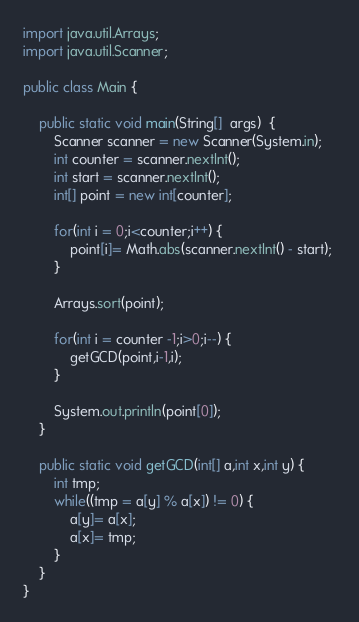Convert code to text. <code><loc_0><loc_0><loc_500><loc_500><_Java_>import java.util.Arrays;
import java.util.Scanner;

public class Main {

	public static void main(String[]  args)  {
		Scanner scanner = new Scanner(System.in);
		int counter = scanner.nextInt();
		int start = scanner.nextInt();
		int[] point = new int[counter];
		
		for(int i = 0;i<counter;i++) {
			point[i]= Math.abs(scanner.nextInt() - start); 
		}
		
		Arrays.sort(point);
		
		for(int i = counter -1;i>0;i--) {
			getGCD(point,i-1,i);
		}
		
		System.out.println(point[0]);
	}
	
	public static void getGCD(int[] a,int x,int y) {
		int tmp;
		while((tmp = a[y] % a[x]) != 0) {
			a[y]= a[x];
			a[x]= tmp; 
		}
	}
}</code> 